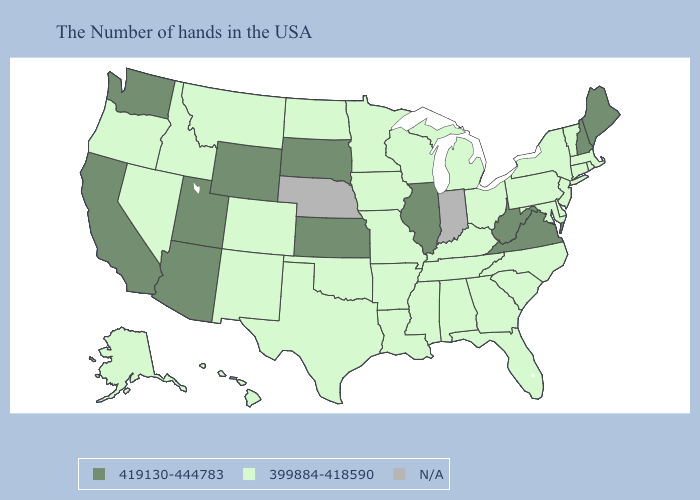What is the value of West Virginia?
Concise answer only. 419130-444783. Does Iowa have the lowest value in the USA?
Keep it brief. Yes. Among the states that border Georgia , which have the highest value?
Answer briefly. North Carolina, South Carolina, Florida, Alabama, Tennessee. Does the first symbol in the legend represent the smallest category?
Be succinct. No. Which states have the lowest value in the USA?
Answer briefly. Massachusetts, Rhode Island, Vermont, Connecticut, New York, New Jersey, Delaware, Maryland, Pennsylvania, North Carolina, South Carolina, Ohio, Florida, Georgia, Michigan, Kentucky, Alabama, Tennessee, Wisconsin, Mississippi, Louisiana, Missouri, Arkansas, Minnesota, Iowa, Oklahoma, Texas, North Dakota, Colorado, New Mexico, Montana, Idaho, Nevada, Oregon, Alaska, Hawaii. Name the states that have a value in the range 399884-418590?
Be succinct. Massachusetts, Rhode Island, Vermont, Connecticut, New York, New Jersey, Delaware, Maryland, Pennsylvania, North Carolina, South Carolina, Ohio, Florida, Georgia, Michigan, Kentucky, Alabama, Tennessee, Wisconsin, Mississippi, Louisiana, Missouri, Arkansas, Minnesota, Iowa, Oklahoma, Texas, North Dakota, Colorado, New Mexico, Montana, Idaho, Nevada, Oregon, Alaska, Hawaii. Which states hav the highest value in the West?
Give a very brief answer. Wyoming, Utah, Arizona, California, Washington. Does Arizona have the highest value in the USA?
Give a very brief answer. Yes. Which states have the highest value in the USA?
Write a very short answer. Maine, New Hampshire, Virginia, West Virginia, Illinois, Kansas, South Dakota, Wyoming, Utah, Arizona, California, Washington. What is the highest value in states that border Oklahoma?
Short answer required. 419130-444783. What is the highest value in the USA?
Write a very short answer. 419130-444783. Is the legend a continuous bar?
Concise answer only. No. Among the states that border North Dakota , does South Dakota have the highest value?
Concise answer only. Yes. 